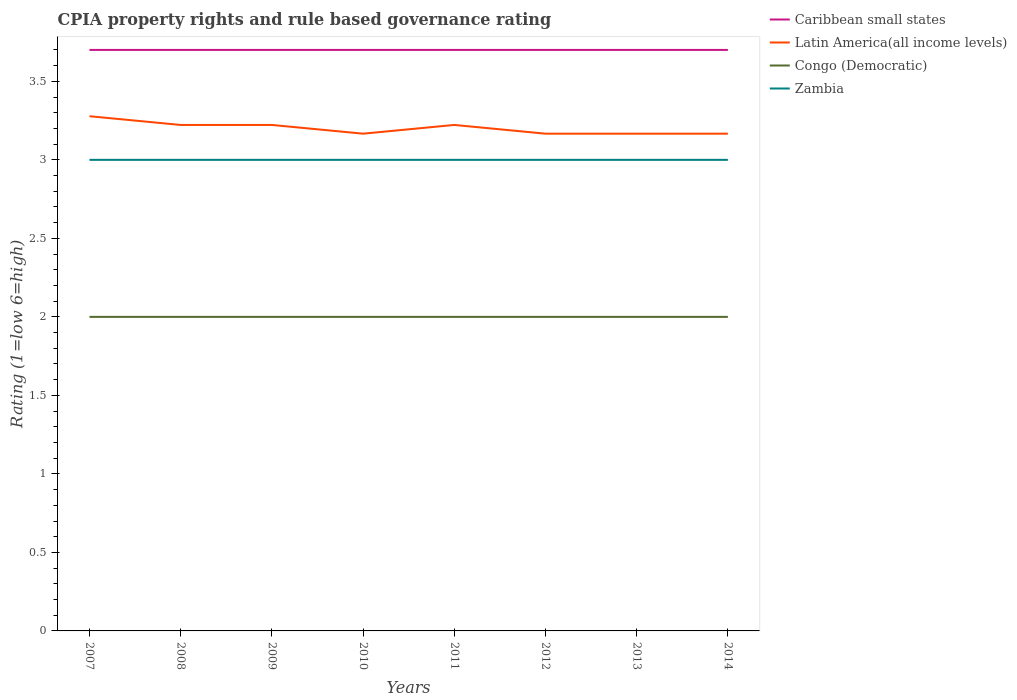How many different coloured lines are there?
Your response must be concise. 4. Across all years, what is the maximum CPIA rating in Zambia?
Keep it short and to the point. 3. In which year was the CPIA rating in Caribbean small states maximum?
Offer a very short reply. 2007. What is the total CPIA rating in Zambia in the graph?
Offer a terse response. 0. Is the CPIA rating in Zambia strictly greater than the CPIA rating in Caribbean small states over the years?
Provide a short and direct response. Yes. How many years are there in the graph?
Provide a short and direct response. 8. What is the difference between two consecutive major ticks on the Y-axis?
Offer a terse response. 0.5. Where does the legend appear in the graph?
Keep it short and to the point. Top right. How are the legend labels stacked?
Ensure brevity in your answer.  Vertical. What is the title of the graph?
Provide a short and direct response. CPIA property rights and rule based governance rating. What is the Rating (1=low 6=high) of Caribbean small states in 2007?
Your answer should be very brief. 3.7. What is the Rating (1=low 6=high) of Latin America(all income levels) in 2007?
Your answer should be very brief. 3.28. What is the Rating (1=low 6=high) in Congo (Democratic) in 2007?
Provide a short and direct response. 2. What is the Rating (1=low 6=high) in Caribbean small states in 2008?
Provide a short and direct response. 3.7. What is the Rating (1=low 6=high) of Latin America(all income levels) in 2008?
Make the answer very short. 3.22. What is the Rating (1=low 6=high) in Congo (Democratic) in 2008?
Provide a succinct answer. 2. What is the Rating (1=low 6=high) of Caribbean small states in 2009?
Keep it short and to the point. 3.7. What is the Rating (1=low 6=high) in Latin America(all income levels) in 2009?
Make the answer very short. 3.22. What is the Rating (1=low 6=high) of Congo (Democratic) in 2009?
Provide a short and direct response. 2. What is the Rating (1=low 6=high) of Zambia in 2009?
Give a very brief answer. 3. What is the Rating (1=low 6=high) in Caribbean small states in 2010?
Give a very brief answer. 3.7. What is the Rating (1=low 6=high) of Latin America(all income levels) in 2010?
Offer a very short reply. 3.17. What is the Rating (1=low 6=high) of Congo (Democratic) in 2010?
Provide a succinct answer. 2. What is the Rating (1=low 6=high) of Zambia in 2010?
Your answer should be very brief. 3. What is the Rating (1=low 6=high) of Caribbean small states in 2011?
Your answer should be compact. 3.7. What is the Rating (1=low 6=high) in Latin America(all income levels) in 2011?
Keep it short and to the point. 3.22. What is the Rating (1=low 6=high) in Congo (Democratic) in 2011?
Provide a short and direct response. 2. What is the Rating (1=low 6=high) in Zambia in 2011?
Offer a terse response. 3. What is the Rating (1=low 6=high) in Caribbean small states in 2012?
Offer a terse response. 3.7. What is the Rating (1=low 6=high) in Latin America(all income levels) in 2012?
Make the answer very short. 3.17. What is the Rating (1=low 6=high) in Congo (Democratic) in 2012?
Keep it short and to the point. 2. What is the Rating (1=low 6=high) in Latin America(all income levels) in 2013?
Offer a very short reply. 3.17. What is the Rating (1=low 6=high) of Congo (Democratic) in 2013?
Offer a very short reply. 2. What is the Rating (1=low 6=high) of Zambia in 2013?
Keep it short and to the point. 3. What is the Rating (1=low 6=high) of Latin America(all income levels) in 2014?
Your answer should be very brief. 3.17. What is the Rating (1=low 6=high) in Zambia in 2014?
Make the answer very short. 3. Across all years, what is the maximum Rating (1=low 6=high) of Caribbean small states?
Give a very brief answer. 3.7. Across all years, what is the maximum Rating (1=low 6=high) of Latin America(all income levels)?
Your response must be concise. 3.28. Across all years, what is the maximum Rating (1=low 6=high) in Congo (Democratic)?
Offer a very short reply. 2. Across all years, what is the minimum Rating (1=low 6=high) of Caribbean small states?
Provide a succinct answer. 3.7. Across all years, what is the minimum Rating (1=low 6=high) in Latin America(all income levels)?
Make the answer very short. 3.17. Across all years, what is the minimum Rating (1=low 6=high) of Congo (Democratic)?
Your answer should be compact. 2. Across all years, what is the minimum Rating (1=low 6=high) in Zambia?
Provide a short and direct response. 3. What is the total Rating (1=low 6=high) of Caribbean small states in the graph?
Offer a very short reply. 29.6. What is the total Rating (1=low 6=high) in Latin America(all income levels) in the graph?
Keep it short and to the point. 25.61. What is the total Rating (1=low 6=high) in Congo (Democratic) in the graph?
Your answer should be compact. 16. What is the difference between the Rating (1=low 6=high) in Caribbean small states in 2007 and that in 2008?
Ensure brevity in your answer.  0. What is the difference between the Rating (1=low 6=high) in Latin America(all income levels) in 2007 and that in 2008?
Ensure brevity in your answer.  0.06. What is the difference between the Rating (1=low 6=high) in Zambia in 2007 and that in 2008?
Offer a terse response. 0. What is the difference between the Rating (1=low 6=high) in Caribbean small states in 2007 and that in 2009?
Offer a terse response. 0. What is the difference between the Rating (1=low 6=high) of Latin America(all income levels) in 2007 and that in 2009?
Give a very brief answer. 0.06. What is the difference between the Rating (1=low 6=high) in Congo (Democratic) in 2007 and that in 2009?
Offer a very short reply. 0. What is the difference between the Rating (1=low 6=high) of Caribbean small states in 2007 and that in 2011?
Your response must be concise. 0. What is the difference between the Rating (1=low 6=high) of Latin America(all income levels) in 2007 and that in 2011?
Offer a very short reply. 0.06. What is the difference between the Rating (1=low 6=high) of Congo (Democratic) in 2007 and that in 2011?
Ensure brevity in your answer.  0. What is the difference between the Rating (1=low 6=high) in Caribbean small states in 2007 and that in 2012?
Provide a succinct answer. 0. What is the difference between the Rating (1=low 6=high) of Congo (Democratic) in 2007 and that in 2012?
Give a very brief answer. 0. What is the difference between the Rating (1=low 6=high) in Caribbean small states in 2007 and that in 2013?
Offer a very short reply. 0. What is the difference between the Rating (1=low 6=high) of Latin America(all income levels) in 2007 and that in 2013?
Keep it short and to the point. 0.11. What is the difference between the Rating (1=low 6=high) of Zambia in 2007 and that in 2013?
Offer a very short reply. 0. What is the difference between the Rating (1=low 6=high) in Caribbean small states in 2008 and that in 2009?
Ensure brevity in your answer.  0. What is the difference between the Rating (1=low 6=high) in Latin America(all income levels) in 2008 and that in 2009?
Ensure brevity in your answer.  0. What is the difference between the Rating (1=low 6=high) in Caribbean small states in 2008 and that in 2010?
Offer a terse response. 0. What is the difference between the Rating (1=low 6=high) in Latin America(all income levels) in 2008 and that in 2010?
Your response must be concise. 0.06. What is the difference between the Rating (1=low 6=high) in Zambia in 2008 and that in 2010?
Provide a succinct answer. 0. What is the difference between the Rating (1=low 6=high) in Caribbean small states in 2008 and that in 2011?
Make the answer very short. 0. What is the difference between the Rating (1=low 6=high) of Congo (Democratic) in 2008 and that in 2011?
Make the answer very short. 0. What is the difference between the Rating (1=low 6=high) of Zambia in 2008 and that in 2011?
Your answer should be very brief. 0. What is the difference between the Rating (1=low 6=high) in Caribbean small states in 2008 and that in 2012?
Give a very brief answer. 0. What is the difference between the Rating (1=low 6=high) of Latin America(all income levels) in 2008 and that in 2012?
Ensure brevity in your answer.  0.06. What is the difference between the Rating (1=low 6=high) of Caribbean small states in 2008 and that in 2013?
Your response must be concise. 0. What is the difference between the Rating (1=low 6=high) in Latin America(all income levels) in 2008 and that in 2013?
Offer a very short reply. 0.06. What is the difference between the Rating (1=low 6=high) in Latin America(all income levels) in 2008 and that in 2014?
Your response must be concise. 0.06. What is the difference between the Rating (1=low 6=high) of Congo (Democratic) in 2008 and that in 2014?
Your response must be concise. 0. What is the difference between the Rating (1=low 6=high) of Zambia in 2008 and that in 2014?
Keep it short and to the point. 0. What is the difference between the Rating (1=low 6=high) in Caribbean small states in 2009 and that in 2010?
Keep it short and to the point. 0. What is the difference between the Rating (1=low 6=high) in Latin America(all income levels) in 2009 and that in 2010?
Your answer should be compact. 0.06. What is the difference between the Rating (1=low 6=high) in Congo (Democratic) in 2009 and that in 2010?
Keep it short and to the point. 0. What is the difference between the Rating (1=low 6=high) in Caribbean small states in 2009 and that in 2011?
Your answer should be compact. 0. What is the difference between the Rating (1=low 6=high) in Congo (Democratic) in 2009 and that in 2011?
Your answer should be very brief. 0. What is the difference between the Rating (1=low 6=high) of Zambia in 2009 and that in 2011?
Offer a terse response. 0. What is the difference between the Rating (1=low 6=high) of Latin America(all income levels) in 2009 and that in 2012?
Your response must be concise. 0.06. What is the difference between the Rating (1=low 6=high) in Latin America(all income levels) in 2009 and that in 2013?
Provide a succinct answer. 0.06. What is the difference between the Rating (1=low 6=high) in Congo (Democratic) in 2009 and that in 2013?
Your answer should be compact. 0. What is the difference between the Rating (1=low 6=high) of Caribbean small states in 2009 and that in 2014?
Your answer should be compact. 0. What is the difference between the Rating (1=low 6=high) in Latin America(all income levels) in 2009 and that in 2014?
Your answer should be very brief. 0.06. What is the difference between the Rating (1=low 6=high) of Congo (Democratic) in 2009 and that in 2014?
Your answer should be compact. 0. What is the difference between the Rating (1=low 6=high) in Caribbean small states in 2010 and that in 2011?
Keep it short and to the point. 0. What is the difference between the Rating (1=low 6=high) in Latin America(all income levels) in 2010 and that in 2011?
Make the answer very short. -0.06. What is the difference between the Rating (1=low 6=high) in Congo (Democratic) in 2010 and that in 2011?
Your answer should be compact. 0. What is the difference between the Rating (1=low 6=high) of Latin America(all income levels) in 2010 and that in 2013?
Offer a terse response. 0. What is the difference between the Rating (1=low 6=high) in Latin America(all income levels) in 2010 and that in 2014?
Offer a terse response. 0. What is the difference between the Rating (1=low 6=high) of Congo (Democratic) in 2010 and that in 2014?
Make the answer very short. 0. What is the difference between the Rating (1=low 6=high) in Latin America(all income levels) in 2011 and that in 2012?
Your response must be concise. 0.06. What is the difference between the Rating (1=low 6=high) in Caribbean small states in 2011 and that in 2013?
Keep it short and to the point. 0. What is the difference between the Rating (1=low 6=high) of Latin America(all income levels) in 2011 and that in 2013?
Provide a short and direct response. 0.06. What is the difference between the Rating (1=low 6=high) of Zambia in 2011 and that in 2013?
Offer a terse response. 0. What is the difference between the Rating (1=low 6=high) of Caribbean small states in 2011 and that in 2014?
Provide a succinct answer. 0. What is the difference between the Rating (1=low 6=high) in Latin America(all income levels) in 2011 and that in 2014?
Your response must be concise. 0.06. What is the difference between the Rating (1=low 6=high) in Zambia in 2011 and that in 2014?
Make the answer very short. 0. What is the difference between the Rating (1=low 6=high) in Latin America(all income levels) in 2012 and that in 2013?
Keep it short and to the point. 0. What is the difference between the Rating (1=low 6=high) of Congo (Democratic) in 2012 and that in 2013?
Make the answer very short. 0. What is the difference between the Rating (1=low 6=high) in Congo (Democratic) in 2012 and that in 2014?
Make the answer very short. 0. What is the difference between the Rating (1=low 6=high) in Caribbean small states in 2013 and that in 2014?
Your answer should be compact. 0. What is the difference between the Rating (1=low 6=high) of Latin America(all income levels) in 2013 and that in 2014?
Provide a succinct answer. 0. What is the difference between the Rating (1=low 6=high) of Zambia in 2013 and that in 2014?
Ensure brevity in your answer.  0. What is the difference between the Rating (1=low 6=high) in Caribbean small states in 2007 and the Rating (1=low 6=high) in Latin America(all income levels) in 2008?
Offer a very short reply. 0.48. What is the difference between the Rating (1=low 6=high) in Latin America(all income levels) in 2007 and the Rating (1=low 6=high) in Congo (Democratic) in 2008?
Make the answer very short. 1.28. What is the difference between the Rating (1=low 6=high) in Latin America(all income levels) in 2007 and the Rating (1=low 6=high) in Zambia in 2008?
Give a very brief answer. 0.28. What is the difference between the Rating (1=low 6=high) in Congo (Democratic) in 2007 and the Rating (1=low 6=high) in Zambia in 2008?
Offer a terse response. -1. What is the difference between the Rating (1=low 6=high) of Caribbean small states in 2007 and the Rating (1=low 6=high) of Latin America(all income levels) in 2009?
Offer a very short reply. 0.48. What is the difference between the Rating (1=low 6=high) of Caribbean small states in 2007 and the Rating (1=low 6=high) of Congo (Democratic) in 2009?
Provide a short and direct response. 1.7. What is the difference between the Rating (1=low 6=high) in Caribbean small states in 2007 and the Rating (1=low 6=high) in Zambia in 2009?
Your response must be concise. 0.7. What is the difference between the Rating (1=low 6=high) of Latin America(all income levels) in 2007 and the Rating (1=low 6=high) of Congo (Democratic) in 2009?
Offer a terse response. 1.28. What is the difference between the Rating (1=low 6=high) of Latin America(all income levels) in 2007 and the Rating (1=low 6=high) of Zambia in 2009?
Offer a terse response. 0.28. What is the difference between the Rating (1=low 6=high) in Congo (Democratic) in 2007 and the Rating (1=low 6=high) in Zambia in 2009?
Make the answer very short. -1. What is the difference between the Rating (1=low 6=high) of Caribbean small states in 2007 and the Rating (1=low 6=high) of Latin America(all income levels) in 2010?
Offer a terse response. 0.53. What is the difference between the Rating (1=low 6=high) of Caribbean small states in 2007 and the Rating (1=low 6=high) of Congo (Democratic) in 2010?
Make the answer very short. 1.7. What is the difference between the Rating (1=low 6=high) in Caribbean small states in 2007 and the Rating (1=low 6=high) in Zambia in 2010?
Give a very brief answer. 0.7. What is the difference between the Rating (1=low 6=high) in Latin America(all income levels) in 2007 and the Rating (1=low 6=high) in Congo (Democratic) in 2010?
Provide a short and direct response. 1.28. What is the difference between the Rating (1=low 6=high) in Latin America(all income levels) in 2007 and the Rating (1=low 6=high) in Zambia in 2010?
Offer a terse response. 0.28. What is the difference between the Rating (1=low 6=high) of Caribbean small states in 2007 and the Rating (1=low 6=high) of Latin America(all income levels) in 2011?
Provide a short and direct response. 0.48. What is the difference between the Rating (1=low 6=high) of Caribbean small states in 2007 and the Rating (1=low 6=high) of Congo (Democratic) in 2011?
Your answer should be compact. 1.7. What is the difference between the Rating (1=low 6=high) of Latin America(all income levels) in 2007 and the Rating (1=low 6=high) of Congo (Democratic) in 2011?
Offer a very short reply. 1.28. What is the difference between the Rating (1=low 6=high) in Latin America(all income levels) in 2007 and the Rating (1=low 6=high) in Zambia in 2011?
Make the answer very short. 0.28. What is the difference between the Rating (1=low 6=high) in Caribbean small states in 2007 and the Rating (1=low 6=high) in Latin America(all income levels) in 2012?
Your response must be concise. 0.53. What is the difference between the Rating (1=low 6=high) in Caribbean small states in 2007 and the Rating (1=low 6=high) in Congo (Democratic) in 2012?
Your response must be concise. 1.7. What is the difference between the Rating (1=low 6=high) in Caribbean small states in 2007 and the Rating (1=low 6=high) in Zambia in 2012?
Ensure brevity in your answer.  0.7. What is the difference between the Rating (1=low 6=high) in Latin America(all income levels) in 2007 and the Rating (1=low 6=high) in Congo (Democratic) in 2012?
Offer a terse response. 1.28. What is the difference between the Rating (1=low 6=high) of Latin America(all income levels) in 2007 and the Rating (1=low 6=high) of Zambia in 2012?
Your response must be concise. 0.28. What is the difference between the Rating (1=low 6=high) of Caribbean small states in 2007 and the Rating (1=low 6=high) of Latin America(all income levels) in 2013?
Ensure brevity in your answer.  0.53. What is the difference between the Rating (1=low 6=high) in Caribbean small states in 2007 and the Rating (1=low 6=high) in Zambia in 2013?
Your response must be concise. 0.7. What is the difference between the Rating (1=low 6=high) in Latin America(all income levels) in 2007 and the Rating (1=low 6=high) in Congo (Democratic) in 2013?
Your answer should be very brief. 1.28. What is the difference between the Rating (1=low 6=high) in Latin America(all income levels) in 2007 and the Rating (1=low 6=high) in Zambia in 2013?
Offer a very short reply. 0.28. What is the difference between the Rating (1=low 6=high) in Congo (Democratic) in 2007 and the Rating (1=low 6=high) in Zambia in 2013?
Keep it short and to the point. -1. What is the difference between the Rating (1=low 6=high) in Caribbean small states in 2007 and the Rating (1=low 6=high) in Latin America(all income levels) in 2014?
Provide a short and direct response. 0.53. What is the difference between the Rating (1=low 6=high) of Caribbean small states in 2007 and the Rating (1=low 6=high) of Zambia in 2014?
Provide a succinct answer. 0.7. What is the difference between the Rating (1=low 6=high) of Latin America(all income levels) in 2007 and the Rating (1=low 6=high) of Congo (Democratic) in 2014?
Your response must be concise. 1.28. What is the difference between the Rating (1=low 6=high) of Latin America(all income levels) in 2007 and the Rating (1=low 6=high) of Zambia in 2014?
Your answer should be compact. 0.28. What is the difference between the Rating (1=low 6=high) of Congo (Democratic) in 2007 and the Rating (1=low 6=high) of Zambia in 2014?
Your answer should be compact. -1. What is the difference between the Rating (1=low 6=high) of Caribbean small states in 2008 and the Rating (1=low 6=high) of Latin America(all income levels) in 2009?
Offer a very short reply. 0.48. What is the difference between the Rating (1=low 6=high) in Latin America(all income levels) in 2008 and the Rating (1=low 6=high) in Congo (Democratic) in 2009?
Give a very brief answer. 1.22. What is the difference between the Rating (1=low 6=high) of Latin America(all income levels) in 2008 and the Rating (1=low 6=high) of Zambia in 2009?
Keep it short and to the point. 0.22. What is the difference between the Rating (1=low 6=high) of Caribbean small states in 2008 and the Rating (1=low 6=high) of Latin America(all income levels) in 2010?
Provide a succinct answer. 0.53. What is the difference between the Rating (1=low 6=high) of Caribbean small states in 2008 and the Rating (1=low 6=high) of Congo (Democratic) in 2010?
Your answer should be very brief. 1.7. What is the difference between the Rating (1=low 6=high) in Latin America(all income levels) in 2008 and the Rating (1=low 6=high) in Congo (Democratic) in 2010?
Give a very brief answer. 1.22. What is the difference between the Rating (1=low 6=high) in Latin America(all income levels) in 2008 and the Rating (1=low 6=high) in Zambia in 2010?
Keep it short and to the point. 0.22. What is the difference between the Rating (1=low 6=high) of Caribbean small states in 2008 and the Rating (1=low 6=high) of Latin America(all income levels) in 2011?
Offer a very short reply. 0.48. What is the difference between the Rating (1=low 6=high) in Caribbean small states in 2008 and the Rating (1=low 6=high) in Congo (Democratic) in 2011?
Your answer should be very brief. 1.7. What is the difference between the Rating (1=low 6=high) in Caribbean small states in 2008 and the Rating (1=low 6=high) in Zambia in 2011?
Your response must be concise. 0.7. What is the difference between the Rating (1=low 6=high) in Latin America(all income levels) in 2008 and the Rating (1=low 6=high) in Congo (Democratic) in 2011?
Your response must be concise. 1.22. What is the difference between the Rating (1=low 6=high) in Latin America(all income levels) in 2008 and the Rating (1=low 6=high) in Zambia in 2011?
Ensure brevity in your answer.  0.22. What is the difference between the Rating (1=low 6=high) in Congo (Democratic) in 2008 and the Rating (1=low 6=high) in Zambia in 2011?
Give a very brief answer. -1. What is the difference between the Rating (1=low 6=high) of Caribbean small states in 2008 and the Rating (1=low 6=high) of Latin America(all income levels) in 2012?
Make the answer very short. 0.53. What is the difference between the Rating (1=low 6=high) in Latin America(all income levels) in 2008 and the Rating (1=low 6=high) in Congo (Democratic) in 2012?
Your response must be concise. 1.22. What is the difference between the Rating (1=low 6=high) of Latin America(all income levels) in 2008 and the Rating (1=low 6=high) of Zambia in 2012?
Your answer should be very brief. 0.22. What is the difference between the Rating (1=low 6=high) in Caribbean small states in 2008 and the Rating (1=low 6=high) in Latin America(all income levels) in 2013?
Keep it short and to the point. 0.53. What is the difference between the Rating (1=low 6=high) of Caribbean small states in 2008 and the Rating (1=low 6=high) of Zambia in 2013?
Offer a terse response. 0.7. What is the difference between the Rating (1=low 6=high) in Latin America(all income levels) in 2008 and the Rating (1=low 6=high) in Congo (Democratic) in 2013?
Provide a short and direct response. 1.22. What is the difference between the Rating (1=low 6=high) in Latin America(all income levels) in 2008 and the Rating (1=low 6=high) in Zambia in 2013?
Make the answer very short. 0.22. What is the difference between the Rating (1=low 6=high) in Congo (Democratic) in 2008 and the Rating (1=low 6=high) in Zambia in 2013?
Offer a very short reply. -1. What is the difference between the Rating (1=low 6=high) of Caribbean small states in 2008 and the Rating (1=low 6=high) of Latin America(all income levels) in 2014?
Give a very brief answer. 0.53. What is the difference between the Rating (1=low 6=high) in Caribbean small states in 2008 and the Rating (1=low 6=high) in Zambia in 2014?
Ensure brevity in your answer.  0.7. What is the difference between the Rating (1=low 6=high) of Latin America(all income levels) in 2008 and the Rating (1=low 6=high) of Congo (Democratic) in 2014?
Offer a very short reply. 1.22. What is the difference between the Rating (1=low 6=high) of Latin America(all income levels) in 2008 and the Rating (1=low 6=high) of Zambia in 2014?
Ensure brevity in your answer.  0.22. What is the difference between the Rating (1=low 6=high) of Caribbean small states in 2009 and the Rating (1=low 6=high) of Latin America(all income levels) in 2010?
Offer a terse response. 0.53. What is the difference between the Rating (1=low 6=high) of Caribbean small states in 2009 and the Rating (1=low 6=high) of Zambia in 2010?
Your response must be concise. 0.7. What is the difference between the Rating (1=low 6=high) of Latin America(all income levels) in 2009 and the Rating (1=low 6=high) of Congo (Democratic) in 2010?
Give a very brief answer. 1.22. What is the difference between the Rating (1=low 6=high) in Latin America(all income levels) in 2009 and the Rating (1=low 6=high) in Zambia in 2010?
Keep it short and to the point. 0.22. What is the difference between the Rating (1=low 6=high) of Caribbean small states in 2009 and the Rating (1=low 6=high) of Latin America(all income levels) in 2011?
Provide a succinct answer. 0.48. What is the difference between the Rating (1=low 6=high) of Caribbean small states in 2009 and the Rating (1=low 6=high) of Zambia in 2011?
Offer a very short reply. 0.7. What is the difference between the Rating (1=low 6=high) of Latin America(all income levels) in 2009 and the Rating (1=low 6=high) of Congo (Democratic) in 2011?
Provide a succinct answer. 1.22. What is the difference between the Rating (1=low 6=high) in Latin America(all income levels) in 2009 and the Rating (1=low 6=high) in Zambia in 2011?
Offer a terse response. 0.22. What is the difference between the Rating (1=low 6=high) in Congo (Democratic) in 2009 and the Rating (1=low 6=high) in Zambia in 2011?
Offer a terse response. -1. What is the difference between the Rating (1=low 6=high) of Caribbean small states in 2009 and the Rating (1=low 6=high) of Latin America(all income levels) in 2012?
Provide a succinct answer. 0.53. What is the difference between the Rating (1=low 6=high) of Caribbean small states in 2009 and the Rating (1=low 6=high) of Zambia in 2012?
Your answer should be compact. 0.7. What is the difference between the Rating (1=low 6=high) in Latin America(all income levels) in 2009 and the Rating (1=low 6=high) in Congo (Democratic) in 2012?
Keep it short and to the point. 1.22. What is the difference between the Rating (1=low 6=high) of Latin America(all income levels) in 2009 and the Rating (1=low 6=high) of Zambia in 2012?
Provide a succinct answer. 0.22. What is the difference between the Rating (1=low 6=high) in Caribbean small states in 2009 and the Rating (1=low 6=high) in Latin America(all income levels) in 2013?
Your answer should be compact. 0.53. What is the difference between the Rating (1=low 6=high) of Caribbean small states in 2009 and the Rating (1=low 6=high) of Congo (Democratic) in 2013?
Make the answer very short. 1.7. What is the difference between the Rating (1=low 6=high) of Latin America(all income levels) in 2009 and the Rating (1=low 6=high) of Congo (Democratic) in 2013?
Offer a very short reply. 1.22. What is the difference between the Rating (1=low 6=high) in Latin America(all income levels) in 2009 and the Rating (1=low 6=high) in Zambia in 2013?
Your response must be concise. 0.22. What is the difference between the Rating (1=low 6=high) of Congo (Democratic) in 2009 and the Rating (1=low 6=high) of Zambia in 2013?
Offer a very short reply. -1. What is the difference between the Rating (1=low 6=high) of Caribbean small states in 2009 and the Rating (1=low 6=high) of Latin America(all income levels) in 2014?
Provide a short and direct response. 0.53. What is the difference between the Rating (1=low 6=high) in Caribbean small states in 2009 and the Rating (1=low 6=high) in Zambia in 2014?
Give a very brief answer. 0.7. What is the difference between the Rating (1=low 6=high) of Latin America(all income levels) in 2009 and the Rating (1=low 6=high) of Congo (Democratic) in 2014?
Your answer should be very brief. 1.22. What is the difference between the Rating (1=low 6=high) of Latin America(all income levels) in 2009 and the Rating (1=low 6=high) of Zambia in 2014?
Your response must be concise. 0.22. What is the difference between the Rating (1=low 6=high) of Congo (Democratic) in 2009 and the Rating (1=low 6=high) of Zambia in 2014?
Keep it short and to the point. -1. What is the difference between the Rating (1=low 6=high) of Caribbean small states in 2010 and the Rating (1=low 6=high) of Latin America(all income levels) in 2011?
Provide a succinct answer. 0.48. What is the difference between the Rating (1=low 6=high) of Caribbean small states in 2010 and the Rating (1=low 6=high) of Congo (Democratic) in 2011?
Provide a succinct answer. 1.7. What is the difference between the Rating (1=low 6=high) in Caribbean small states in 2010 and the Rating (1=low 6=high) in Zambia in 2011?
Provide a succinct answer. 0.7. What is the difference between the Rating (1=low 6=high) of Latin America(all income levels) in 2010 and the Rating (1=low 6=high) of Congo (Democratic) in 2011?
Your answer should be compact. 1.17. What is the difference between the Rating (1=low 6=high) in Caribbean small states in 2010 and the Rating (1=low 6=high) in Latin America(all income levels) in 2012?
Your response must be concise. 0.53. What is the difference between the Rating (1=low 6=high) of Latin America(all income levels) in 2010 and the Rating (1=low 6=high) of Zambia in 2012?
Provide a succinct answer. 0.17. What is the difference between the Rating (1=low 6=high) of Caribbean small states in 2010 and the Rating (1=low 6=high) of Latin America(all income levels) in 2013?
Provide a succinct answer. 0.53. What is the difference between the Rating (1=low 6=high) of Caribbean small states in 2010 and the Rating (1=low 6=high) of Congo (Democratic) in 2013?
Provide a short and direct response. 1.7. What is the difference between the Rating (1=low 6=high) in Latin America(all income levels) in 2010 and the Rating (1=low 6=high) in Congo (Democratic) in 2013?
Your answer should be compact. 1.17. What is the difference between the Rating (1=low 6=high) of Latin America(all income levels) in 2010 and the Rating (1=low 6=high) of Zambia in 2013?
Give a very brief answer. 0.17. What is the difference between the Rating (1=low 6=high) of Congo (Democratic) in 2010 and the Rating (1=low 6=high) of Zambia in 2013?
Your answer should be compact. -1. What is the difference between the Rating (1=low 6=high) in Caribbean small states in 2010 and the Rating (1=low 6=high) in Latin America(all income levels) in 2014?
Provide a succinct answer. 0.53. What is the difference between the Rating (1=low 6=high) of Latin America(all income levels) in 2010 and the Rating (1=low 6=high) of Zambia in 2014?
Provide a short and direct response. 0.17. What is the difference between the Rating (1=low 6=high) of Congo (Democratic) in 2010 and the Rating (1=low 6=high) of Zambia in 2014?
Offer a terse response. -1. What is the difference between the Rating (1=low 6=high) in Caribbean small states in 2011 and the Rating (1=low 6=high) in Latin America(all income levels) in 2012?
Ensure brevity in your answer.  0.53. What is the difference between the Rating (1=low 6=high) in Caribbean small states in 2011 and the Rating (1=low 6=high) in Zambia in 2012?
Your response must be concise. 0.7. What is the difference between the Rating (1=low 6=high) in Latin America(all income levels) in 2011 and the Rating (1=low 6=high) in Congo (Democratic) in 2012?
Your response must be concise. 1.22. What is the difference between the Rating (1=low 6=high) in Latin America(all income levels) in 2011 and the Rating (1=low 6=high) in Zambia in 2012?
Give a very brief answer. 0.22. What is the difference between the Rating (1=low 6=high) of Caribbean small states in 2011 and the Rating (1=low 6=high) of Latin America(all income levels) in 2013?
Make the answer very short. 0.53. What is the difference between the Rating (1=low 6=high) of Caribbean small states in 2011 and the Rating (1=low 6=high) of Zambia in 2013?
Offer a terse response. 0.7. What is the difference between the Rating (1=low 6=high) of Latin America(all income levels) in 2011 and the Rating (1=low 6=high) of Congo (Democratic) in 2013?
Keep it short and to the point. 1.22. What is the difference between the Rating (1=low 6=high) of Latin America(all income levels) in 2011 and the Rating (1=low 6=high) of Zambia in 2013?
Offer a terse response. 0.22. What is the difference between the Rating (1=low 6=high) in Caribbean small states in 2011 and the Rating (1=low 6=high) in Latin America(all income levels) in 2014?
Your answer should be very brief. 0.53. What is the difference between the Rating (1=low 6=high) in Latin America(all income levels) in 2011 and the Rating (1=low 6=high) in Congo (Democratic) in 2014?
Ensure brevity in your answer.  1.22. What is the difference between the Rating (1=low 6=high) in Latin America(all income levels) in 2011 and the Rating (1=low 6=high) in Zambia in 2014?
Ensure brevity in your answer.  0.22. What is the difference between the Rating (1=low 6=high) of Congo (Democratic) in 2011 and the Rating (1=low 6=high) of Zambia in 2014?
Provide a succinct answer. -1. What is the difference between the Rating (1=low 6=high) of Caribbean small states in 2012 and the Rating (1=low 6=high) of Latin America(all income levels) in 2013?
Give a very brief answer. 0.53. What is the difference between the Rating (1=low 6=high) of Caribbean small states in 2012 and the Rating (1=low 6=high) of Congo (Democratic) in 2013?
Offer a terse response. 1.7. What is the difference between the Rating (1=low 6=high) in Latin America(all income levels) in 2012 and the Rating (1=low 6=high) in Congo (Democratic) in 2013?
Keep it short and to the point. 1.17. What is the difference between the Rating (1=low 6=high) in Congo (Democratic) in 2012 and the Rating (1=low 6=high) in Zambia in 2013?
Provide a succinct answer. -1. What is the difference between the Rating (1=low 6=high) of Caribbean small states in 2012 and the Rating (1=low 6=high) of Latin America(all income levels) in 2014?
Offer a very short reply. 0.53. What is the difference between the Rating (1=low 6=high) of Caribbean small states in 2012 and the Rating (1=low 6=high) of Zambia in 2014?
Provide a succinct answer. 0.7. What is the difference between the Rating (1=low 6=high) of Caribbean small states in 2013 and the Rating (1=low 6=high) of Latin America(all income levels) in 2014?
Your answer should be very brief. 0.53. What is the difference between the Rating (1=low 6=high) of Caribbean small states in 2013 and the Rating (1=low 6=high) of Congo (Democratic) in 2014?
Offer a terse response. 1.7. What is the difference between the Rating (1=low 6=high) of Caribbean small states in 2013 and the Rating (1=low 6=high) of Zambia in 2014?
Offer a terse response. 0.7. What is the difference between the Rating (1=low 6=high) of Latin America(all income levels) in 2013 and the Rating (1=low 6=high) of Congo (Democratic) in 2014?
Your answer should be compact. 1.17. What is the difference between the Rating (1=low 6=high) of Latin America(all income levels) in 2013 and the Rating (1=low 6=high) of Zambia in 2014?
Give a very brief answer. 0.17. What is the difference between the Rating (1=low 6=high) of Congo (Democratic) in 2013 and the Rating (1=low 6=high) of Zambia in 2014?
Your response must be concise. -1. What is the average Rating (1=low 6=high) in Caribbean small states per year?
Your answer should be very brief. 3.7. What is the average Rating (1=low 6=high) in Latin America(all income levels) per year?
Make the answer very short. 3.2. What is the average Rating (1=low 6=high) of Congo (Democratic) per year?
Give a very brief answer. 2. In the year 2007, what is the difference between the Rating (1=low 6=high) in Caribbean small states and Rating (1=low 6=high) in Latin America(all income levels)?
Make the answer very short. 0.42. In the year 2007, what is the difference between the Rating (1=low 6=high) in Caribbean small states and Rating (1=low 6=high) in Congo (Democratic)?
Give a very brief answer. 1.7. In the year 2007, what is the difference between the Rating (1=low 6=high) in Caribbean small states and Rating (1=low 6=high) in Zambia?
Provide a short and direct response. 0.7. In the year 2007, what is the difference between the Rating (1=low 6=high) in Latin America(all income levels) and Rating (1=low 6=high) in Congo (Democratic)?
Ensure brevity in your answer.  1.28. In the year 2007, what is the difference between the Rating (1=low 6=high) in Latin America(all income levels) and Rating (1=low 6=high) in Zambia?
Offer a terse response. 0.28. In the year 2008, what is the difference between the Rating (1=low 6=high) in Caribbean small states and Rating (1=low 6=high) in Latin America(all income levels)?
Your response must be concise. 0.48. In the year 2008, what is the difference between the Rating (1=low 6=high) in Latin America(all income levels) and Rating (1=low 6=high) in Congo (Democratic)?
Your answer should be compact. 1.22. In the year 2008, what is the difference between the Rating (1=low 6=high) in Latin America(all income levels) and Rating (1=low 6=high) in Zambia?
Your response must be concise. 0.22. In the year 2009, what is the difference between the Rating (1=low 6=high) of Caribbean small states and Rating (1=low 6=high) of Latin America(all income levels)?
Provide a short and direct response. 0.48. In the year 2009, what is the difference between the Rating (1=low 6=high) in Caribbean small states and Rating (1=low 6=high) in Zambia?
Your response must be concise. 0.7. In the year 2009, what is the difference between the Rating (1=low 6=high) in Latin America(all income levels) and Rating (1=low 6=high) in Congo (Democratic)?
Provide a succinct answer. 1.22. In the year 2009, what is the difference between the Rating (1=low 6=high) in Latin America(all income levels) and Rating (1=low 6=high) in Zambia?
Provide a short and direct response. 0.22. In the year 2009, what is the difference between the Rating (1=low 6=high) in Congo (Democratic) and Rating (1=low 6=high) in Zambia?
Your response must be concise. -1. In the year 2010, what is the difference between the Rating (1=low 6=high) of Caribbean small states and Rating (1=low 6=high) of Latin America(all income levels)?
Provide a succinct answer. 0.53. In the year 2011, what is the difference between the Rating (1=low 6=high) of Caribbean small states and Rating (1=low 6=high) of Latin America(all income levels)?
Ensure brevity in your answer.  0.48. In the year 2011, what is the difference between the Rating (1=low 6=high) in Latin America(all income levels) and Rating (1=low 6=high) in Congo (Democratic)?
Provide a succinct answer. 1.22. In the year 2011, what is the difference between the Rating (1=low 6=high) of Latin America(all income levels) and Rating (1=low 6=high) of Zambia?
Ensure brevity in your answer.  0.22. In the year 2012, what is the difference between the Rating (1=low 6=high) of Caribbean small states and Rating (1=low 6=high) of Latin America(all income levels)?
Your answer should be compact. 0.53. In the year 2012, what is the difference between the Rating (1=low 6=high) of Caribbean small states and Rating (1=low 6=high) of Congo (Democratic)?
Your answer should be very brief. 1.7. In the year 2012, what is the difference between the Rating (1=low 6=high) of Caribbean small states and Rating (1=low 6=high) of Zambia?
Your response must be concise. 0.7. In the year 2012, what is the difference between the Rating (1=low 6=high) of Latin America(all income levels) and Rating (1=low 6=high) of Congo (Democratic)?
Provide a short and direct response. 1.17. In the year 2012, what is the difference between the Rating (1=low 6=high) in Congo (Democratic) and Rating (1=low 6=high) in Zambia?
Offer a very short reply. -1. In the year 2013, what is the difference between the Rating (1=low 6=high) in Caribbean small states and Rating (1=low 6=high) in Latin America(all income levels)?
Make the answer very short. 0.53. In the year 2013, what is the difference between the Rating (1=low 6=high) of Caribbean small states and Rating (1=low 6=high) of Congo (Democratic)?
Provide a short and direct response. 1.7. In the year 2014, what is the difference between the Rating (1=low 6=high) in Caribbean small states and Rating (1=low 6=high) in Latin America(all income levels)?
Offer a terse response. 0.53. In the year 2014, what is the difference between the Rating (1=low 6=high) of Caribbean small states and Rating (1=low 6=high) of Zambia?
Offer a very short reply. 0.7. In the year 2014, what is the difference between the Rating (1=low 6=high) of Latin America(all income levels) and Rating (1=low 6=high) of Zambia?
Offer a very short reply. 0.17. In the year 2014, what is the difference between the Rating (1=low 6=high) in Congo (Democratic) and Rating (1=low 6=high) in Zambia?
Make the answer very short. -1. What is the ratio of the Rating (1=low 6=high) in Latin America(all income levels) in 2007 to that in 2008?
Provide a short and direct response. 1.02. What is the ratio of the Rating (1=low 6=high) of Congo (Democratic) in 2007 to that in 2008?
Your response must be concise. 1. What is the ratio of the Rating (1=low 6=high) of Zambia in 2007 to that in 2008?
Provide a short and direct response. 1. What is the ratio of the Rating (1=low 6=high) in Latin America(all income levels) in 2007 to that in 2009?
Provide a succinct answer. 1.02. What is the ratio of the Rating (1=low 6=high) of Latin America(all income levels) in 2007 to that in 2010?
Offer a terse response. 1.04. What is the ratio of the Rating (1=low 6=high) in Latin America(all income levels) in 2007 to that in 2011?
Your answer should be very brief. 1.02. What is the ratio of the Rating (1=low 6=high) in Congo (Democratic) in 2007 to that in 2011?
Provide a succinct answer. 1. What is the ratio of the Rating (1=low 6=high) of Latin America(all income levels) in 2007 to that in 2012?
Offer a very short reply. 1.04. What is the ratio of the Rating (1=low 6=high) in Congo (Democratic) in 2007 to that in 2012?
Your answer should be very brief. 1. What is the ratio of the Rating (1=low 6=high) in Zambia in 2007 to that in 2012?
Your response must be concise. 1. What is the ratio of the Rating (1=low 6=high) of Latin America(all income levels) in 2007 to that in 2013?
Provide a short and direct response. 1.04. What is the ratio of the Rating (1=low 6=high) of Congo (Democratic) in 2007 to that in 2013?
Make the answer very short. 1. What is the ratio of the Rating (1=low 6=high) of Caribbean small states in 2007 to that in 2014?
Provide a succinct answer. 1. What is the ratio of the Rating (1=low 6=high) of Latin America(all income levels) in 2007 to that in 2014?
Make the answer very short. 1.04. What is the ratio of the Rating (1=low 6=high) of Latin America(all income levels) in 2008 to that in 2010?
Ensure brevity in your answer.  1.02. What is the ratio of the Rating (1=low 6=high) in Latin America(all income levels) in 2008 to that in 2011?
Your answer should be very brief. 1. What is the ratio of the Rating (1=low 6=high) in Congo (Democratic) in 2008 to that in 2011?
Offer a terse response. 1. What is the ratio of the Rating (1=low 6=high) of Zambia in 2008 to that in 2011?
Provide a succinct answer. 1. What is the ratio of the Rating (1=low 6=high) of Latin America(all income levels) in 2008 to that in 2012?
Offer a terse response. 1.02. What is the ratio of the Rating (1=low 6=high) of Congo (Democratic) in 2008 to that in 2012?
Provide a short and direct response. 1. What is the ratio of the Rating (1=low 6=high) in Zambia in 2008 to that in 2012?
Provide a short and direct response. 1. What is the ratio of the Rating (1=low 6=high) of Latin America(all income levels) in 2008 to that in 2013?
Make the answer very short. 1.02. What is the ratio of the Rating (1=low 6=high) in Zambia in 2008 to that in 2013?
Make the answer very short. 1. What is the ratio of the Rating (1=low 6=high) of Latin America(all income levels) in 2008 to that in 2014?
Ensure brevity in your answer.  1.02. What is the ratio of the Rating (1=low 6=high) of Congo (Democratic) in 2008 to that in 2014?
Your response must be concise. 1. What is the ratio of the Rating (1=low 6=high) in Zambia in 2008 to that in 2014?
Ensure brevity in your answer.  1. What is the ratio of the Rating (1=low 6=high) of Caribbean small states in 2009 to that in 2010?
Provide a succinct answer. 1. What is the ratio of the Rating (1=low 6=high) in Latin America(all income levels) in 2009 to that in 2010?
Provide a succinct answer. 1.02. What is the ratio of the Rating (1=low 6=high) of Congo (Democratic) in 2009 to that in 2011?
Keep it short and to the point. 1. What is the ratio of the Rating (1=low 6=high) in Zambia in 2009 to that in 2011?
Your response must be concise. 1. What is the ratio of the Rating (1=low 6=high) of Latin America(all income levels) in 2009 to that in 2012?
Provide a succinct answer. 1.02. What is the ratio of the Rating (1=low 6=high) in Caribbean small states in 2009 to that in 2013?
Keep it short and to the point. 1. What is the ratio of the Rating (1=low 6=high) in Latin America(all income levels) in 2009 to that in 2013?
Your answer should be very brief. 1.02. What is the ratio of the Rating (1=low 6=high) of Latin America(all income levels) in 2009 to that in 2014?
Give a very brief answer. 1.02. What is the ratio of the Rating (1=low 6=high) of Caribbean small states in 2010 to that in 2011?
Your response must be concise. 1. What is the ratio of the Rating (1=low 6=high) of Latin America(all income levels) in 2010 to that in 2011?
Offer a terse response. 0.98. What is the ratio of the Rating (1=low 6=high) in Latin America(all income levels) in 2010 to that in 2012?
Provide a short and direct response. 1. What is the ratio of the Rating (1=low 6=high) in Zambia in 2010 to that in 2012?
Offer a very short reply. 1. What is the ratio of the Rating (1=low 6=high) in Caribbean small states in 2010 to that in 2013?
Offer a terse response. 1. What is the ratio of the Rating (1=low 6=high) of Latin America(all income levels) in 2010 to that in 2013?
Make the answer very short. 1. What is the ratio of the Rating (1=low 6=high) in Congo (Democratic) in 2010 to that in 2013?
Provide a succinct answer. 1. What is the ratio of the Rating (1=low 6=high) in Latin America(all income levels) in 2010 to that in 2014?
Offer a terse response. 1. What is the ratio of the Rating (1=low 6=high) of Zambia in 2010 to that in 2014?
Provide a succinct answer. 1. What is the ratio of the Rating (1=low 6=high) of Latin America(all income levels) in 2011 to that in 2012?
Offer a very short reply. 1.02. What is the ratio of the Rating (1=low 6=high) in Congo (Democratic) in 2011 to that in 2012?
Offer a terse response. 1. What is the ratio of the Rating (1=low 6=high) in Zambia in 2011 to that in 2012?
Make the answer very short. 1. What is the ratio of the Rating (1=low 6=high) of Caribbean small states in 2011 to that in 2013?
Provide a succinct answer. 1. What is the ratio of the Rating (1=low 6=high) of Latin America(all income levels) in 2011 to that in 2013?
Provide a succinct answer. 1.02. What is the ratio of the Rating (1=low 6=high) in Zambia in 2011 to that in 2013?
Keep it short and to the point. 1. What is the ratio of the Rating (1=low 6=high) of Latin America(all income levels) in 2011 to that in 2014?
Offer a terse response. 1.02. What is the ratio of the Rating (1=low 6=high) of Zambia in 2011 to that in 2014?
Give a very brief answer. 1. What is the ratio of the Rating (1=low 6=high) of Latin America(all income levels) in 2012 to that in 2013?
Provide a short and direct response. 1. What is the ratio of the Rating (1=low 6=high) in Congo (Democratic) in 2012 to that in 2013?
Your answer should be compact. 1. What is the ratio of the Rating (1=low 6=high) in Caribbean small states in 2012 to that in 2014?
Keep it short and to the point. 1. What is the ratio of the Rating (1=low 6=high) in Congo (Democratic) in 2012 to that in 2014?
Give a very brief answer. 1. What is the ratio of the Rating (1=low 6=high) of Zambia in 2012 to that in 2014?
Give a very brief answer. 1. What is the ratio of the Rating (1=low 6=high) of Caribbean small states in 2013 to that in 2014?
Offer a terse response. 1. What is the ratio of the Rating (1=low 6=high) of Latin America(all income levels) in 2013 to that in 2014?
Provide a succinct answer. 1. What is the ratio of the Rating (1=low 6=high) in Zambia in 2013 to that in 2014?
Ensure brevity in your answer.  1. What is the difference between the highest and the second highest Rating (1=low 6=high) of Caribbean small states?
Your answer should be very brief. 0. What is the difference between the highest and the second highest Rating (1=low 6=high) in Latin America(all income levels)?
Your answer should be very brief. 0.06. What is the difference between the highest and the second highest Rating (1=low 6=high) in Congo (Democratic)?
Offer a terse response. 0. What is the difference between the highest and the lowest Rating (1=low 6=high) of Caribbean small states?
Keep it short and to the point. 0. What is the difference between the highest and the lowest Rating (1=low 6=high) in Latin America(all income levels)?
Provide a short and direct response. 0.11. What is the difference between the highest and the lowest Rating (1=low 6=high) in Congo (Democratic)?
Your response must be concise. 0. 